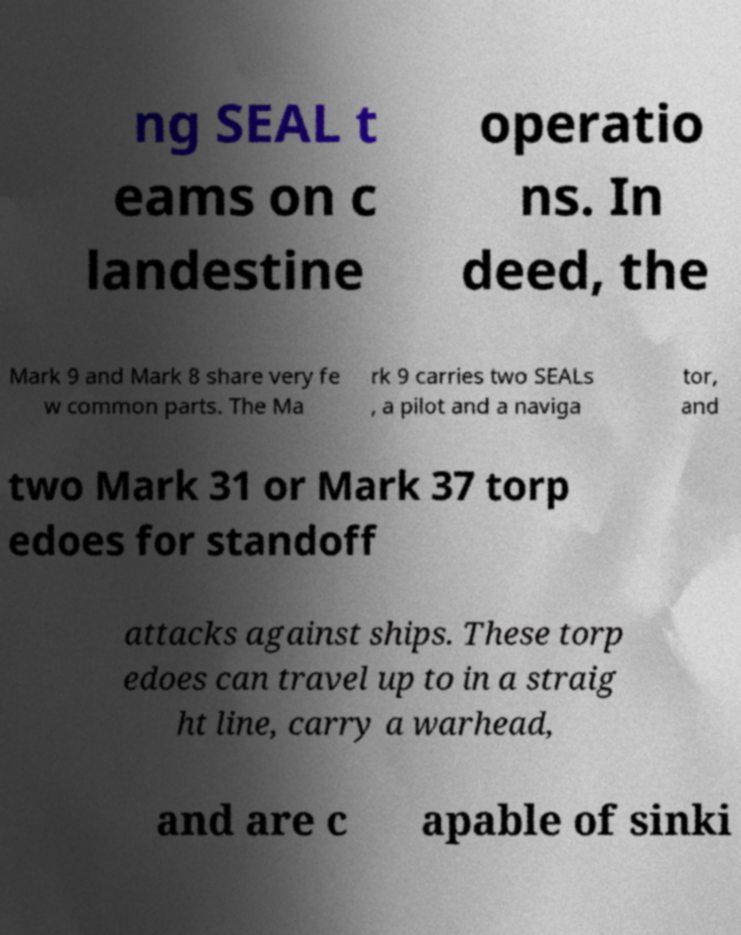For documentation purposes, I need the text within this image transcribed. Could you provide that? ng SEAL t eams on c landestine operatio ns. In deed, the Mark 9 and Mark 8 share very fe w common parts. The Ma rk 9 carries two SEALs , a pilot and a naviga tor, and two Mark 31 or Mark 37 torp edoes for standoff attacks against ships. These torp edoes can travel up to in a straig ht line, carry a warhead, and are c apable of sinki 